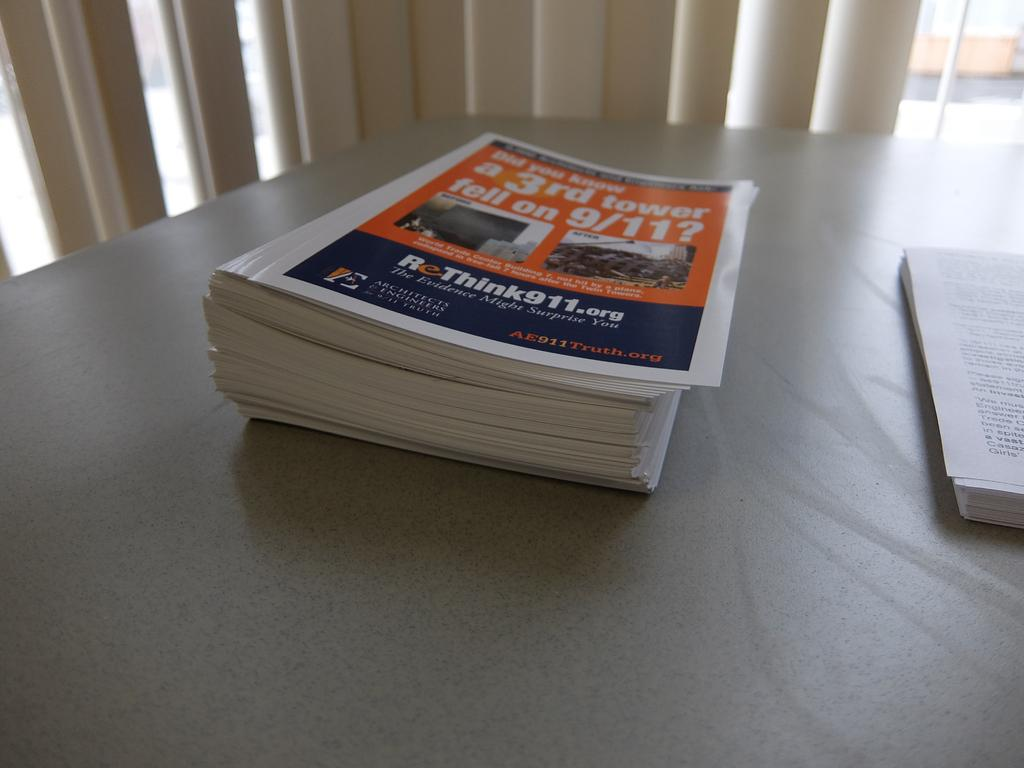<image>
Create a compact narrative representing the image presented. A stack of papers that discuss rethinking 9/11. 